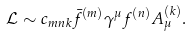Convert formula to latex. <formula><loc_0><loc_0><loc_500><loc_500>\mathcal { L } \sim c _ { m n k } \bar { f } ^ { ( m ) } \gamma ^ { \mu } f ^ { ( n ) } A _ { \mu } ^ { ( k ) } .</formula> 